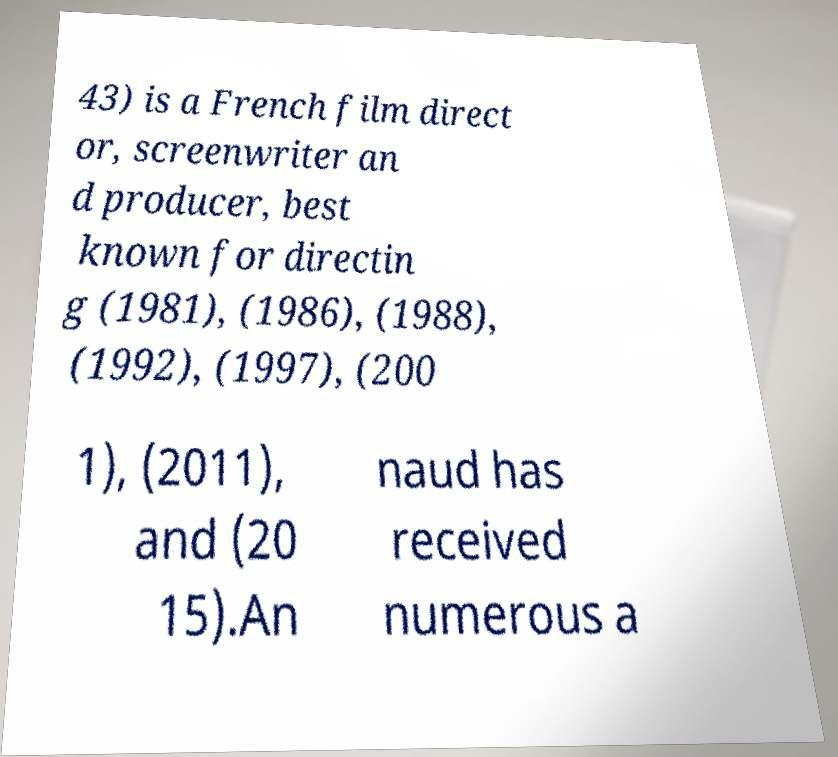Can you read and provide the text displayed in the image?This photo seems to have some interesting text. Can you extract and type it out for me? 43) is a French film direct or, screenwriter an d producer, best known for directin g (1981), (1986), (1988), (1992), (1997), (200 1), (2011), and (20 15).An naud has received numerous a 